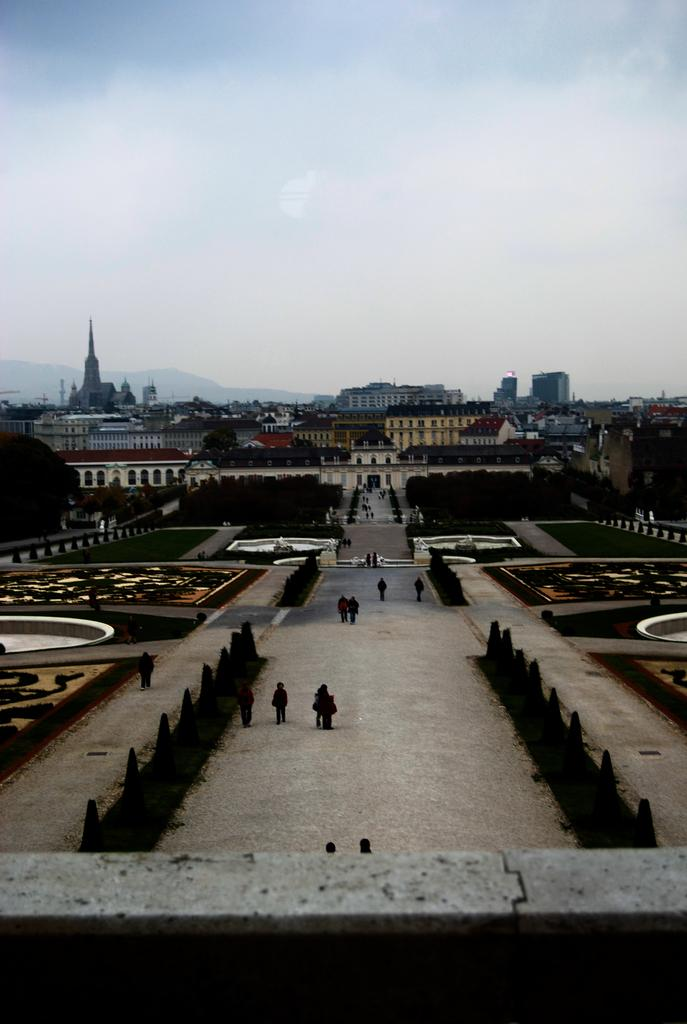What type of structures can be seen in the image? There are buildings in the image. What natural elements are present in the image? There are trees and plants in the image. Can you describe the people in the image? There are people in the image. What is the ground like in the image? The ground is visible in the image, and there is grass on the ground. What objects can be seen on the ground? There are objects on the ground in the image. What part of the natural environment is visible in the image? The sky is visible in the image. What type of fuel is being used by the achiever in the image? There is no achiever or fuel present in the image. What type of man is depicted in the image? The provided facts do not mention a specific man or any details about a man in the image. 